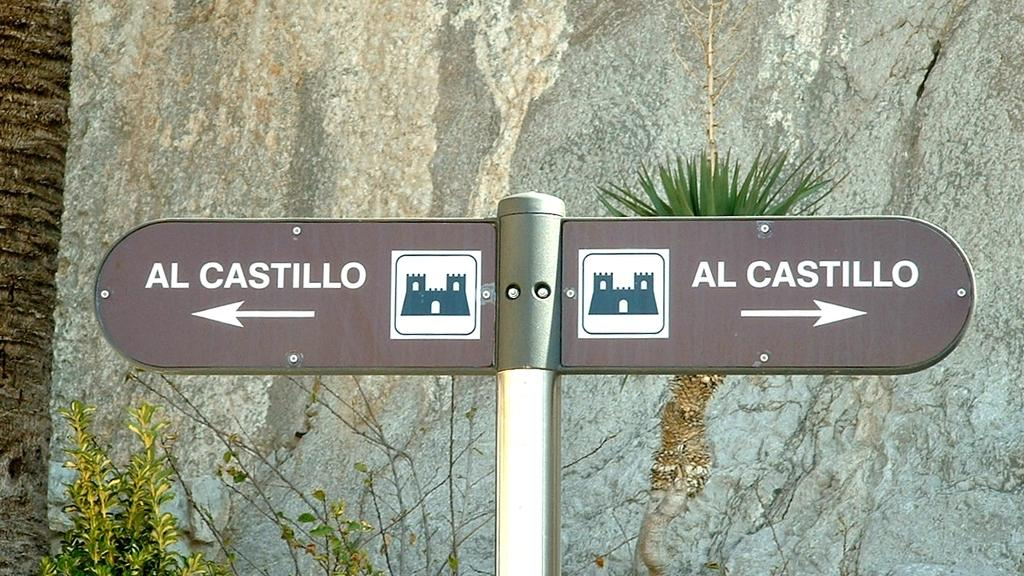What is on the pole in the image? There is a direction board on a pole in the image. What can be seen in the background of the image? There are plants and a big rock in the background of the image. What is on the left side of the image? There is a truncated tree on the left side of the image. Can you see a girl looking out of the window in the image? There is no window or girl present in the image. 